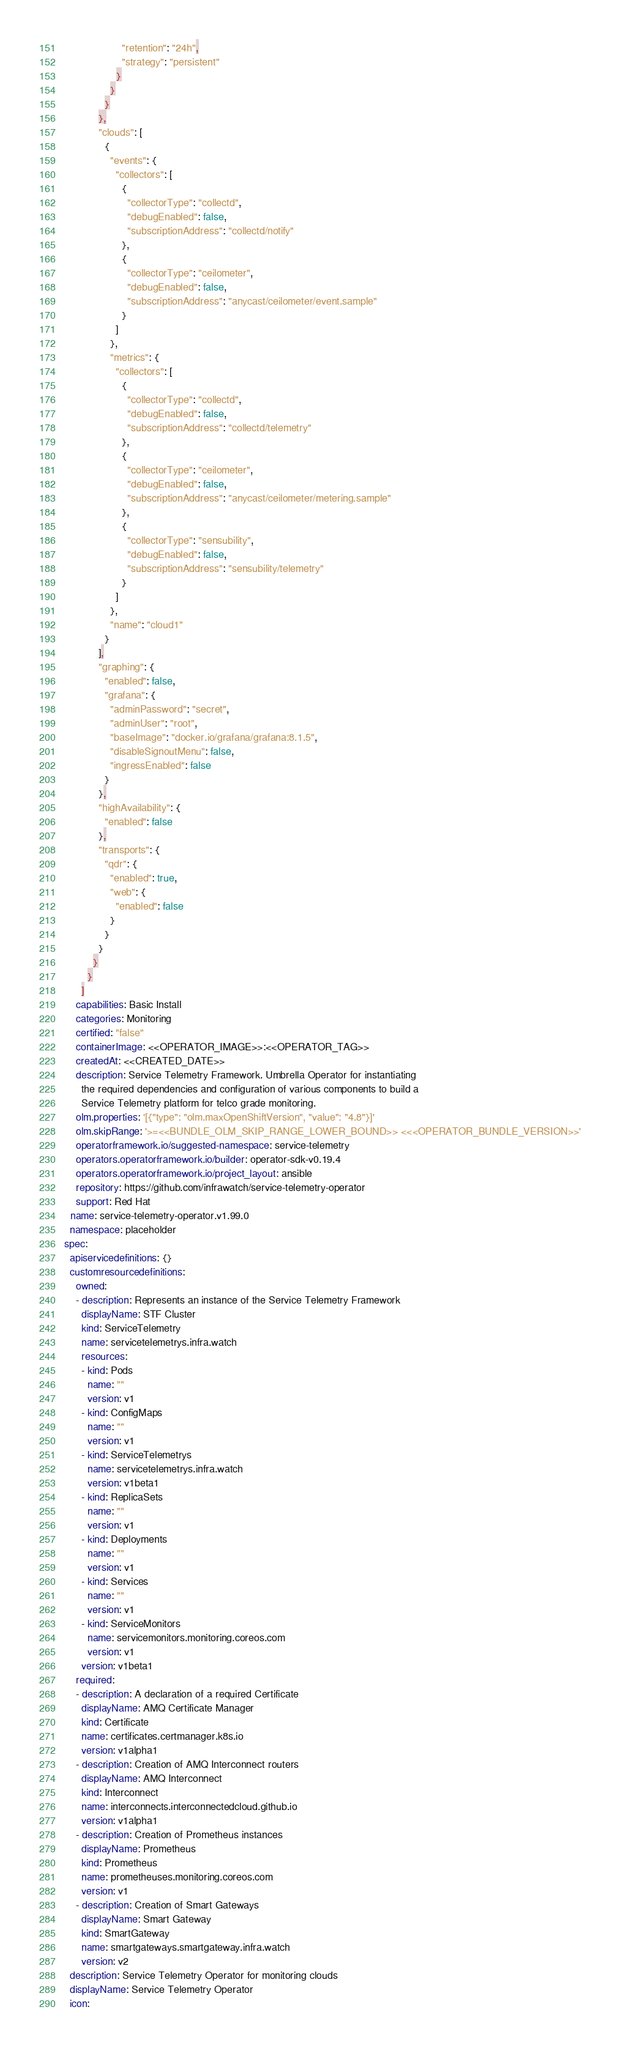<code> <loc_0><loc_0><loc_500><loc_500><_YAML_>                    "retention": "24h",
                    "strategy": "persistent"
                  }
                }
              }
            },
            "clouds": [
              {
                "events": {
                  "collectors": [
                    {
                      "collectorType": "collectd",
                      "debugEnabled": false,
                      "subscriptionAddress": "collectd/notify"
                    },
                    {
                      "collectorType": "ceilometer",
                      "debugEnabled": false,
                      "subscriptionAddress": "anycast/ceilometer/event.sample"
                    }
                  ]
                },
                "metrics": {
                  "collectors": [
                    {
                      "collectorType": "collectd",
                      "debugEnabled": false,
                      "subscriptionAddress": "collectd/telemetry"
                    },
                    {
                      "collectorType": "ceilometer",
                      "debugEnabled": false,
                      "subscriptionAddress": "anycast/ceilometer/metering.sample"
                    },
                    {
                      "collectorType": "sensubility",
                      "debugEnabled": false,
                      "subscriptionAddress": "sensubility/telemetry"
                    }
                  ]
                },
                "name": "cloud1"
              }
            ],
            "graphing": {
              "enabled": false,
              "grafana": {
                "adminPassword": "secret",
                "adminUser": "root",
                "baseImage": "docker.io/grafana/grafana:8.1.5",
                "disableSignoutMenu": false,
                "ingressEnabled": false
              }
            },
            "highAvailability": {
              "enabled": false
            },
            "transports": {
              "qdr": {
                "enabled": true,
                "web": {
                  "enabled": false
                }
              }
            }
          }
        }
      ]
    capabilities: Basic Install
    categories: Monitoring
    certified: "false"
    containerImage: <<OPERATOR_IMAGE>>:<<OPERATOR_TAG>>
    createdAt: <<CREATED_DATE>>
    description: Service Telemetry Framework. Umbrella Operator for instantiating
      the required dependencies and configuration of various components to build a
      Service Telemetry platform for telco grade monitoring.
    olm.properties: '[{"type": "olm.maxOpenShiftVersion", "value": "4.8"}]'
    olm.skipRange: '>=<<BUNDLE_OLM_SKIP_RANGE_LOWER_BOUND>> <<<OPERATOR_BUNDLE_VERSION>>'
    operatorframework.io/suggested-namespace: service-telemetry
    operators.operatorframework.io/builder: operator-sdk-v0.19.4
    operators.operatorframework.io/project_layout: ansible
    repository: https://github.com/infrawatch/service-telemetry-operator
    support: Red Hat
  name: service-telemetry-operator.v1.99.0
  namespace: placeholder
spec:
  apiservicedefinitions: {}
  customresourcedefinitions:
    owned:
    - description: Represents an instance of the Service Telemetry Framework
      displayName: STF Cluster
      kind: ServiceTelemetry
      name: servicetelemetrys.infra.watch
      resources:
      - kind: Pods
        name: ""
        version: v1
      - kind: ConfigMaps
        name: ""
        version: v1
      - kind: ServiceTelemetrys
        name: servicetelemetrys.infra.watch
        version: v1beta1
      - kind: ReplicaSets
        name: ""
        version: v1
      - kind: Deployments
        name: ""
        version: v1
      - kind: Services
        name: ""
        version: v1
      - kind: ServiceMonitors
        name: servicemonitors.monitoring.coreos.com
        version: v1
      version: v1beta1
    required:
    - description: A declaration of a required Certificate
      displayName: AMQ Certificate Manager
      kind: Certificate
      name: certificates.certmanager.k8s.io
      version: v1alpha1
    - description: Creation of AMQ Interconnect routers
      displayName: AMQ Interconnect
      kind: Interconnect
      name: interconnects.interconnectedcloud.github.io
      version: v1alpha1
    - description: Creation of Prometheus instances
      displayName: Prometheus
      kind: Prometheus
      name: prometheuses.monitoring.coreos.com
      version: v1
    - description: Creation of Smart Gateways
      displayName: Smart Gateway
      kind: SmartGateway
      name: smartgateways.smartgateway.infra.watch
      version: v2
  description: Service Telemetry Operator for monitoring clouds
  displayName: Service Telemetry Operator
  icon:</code> 